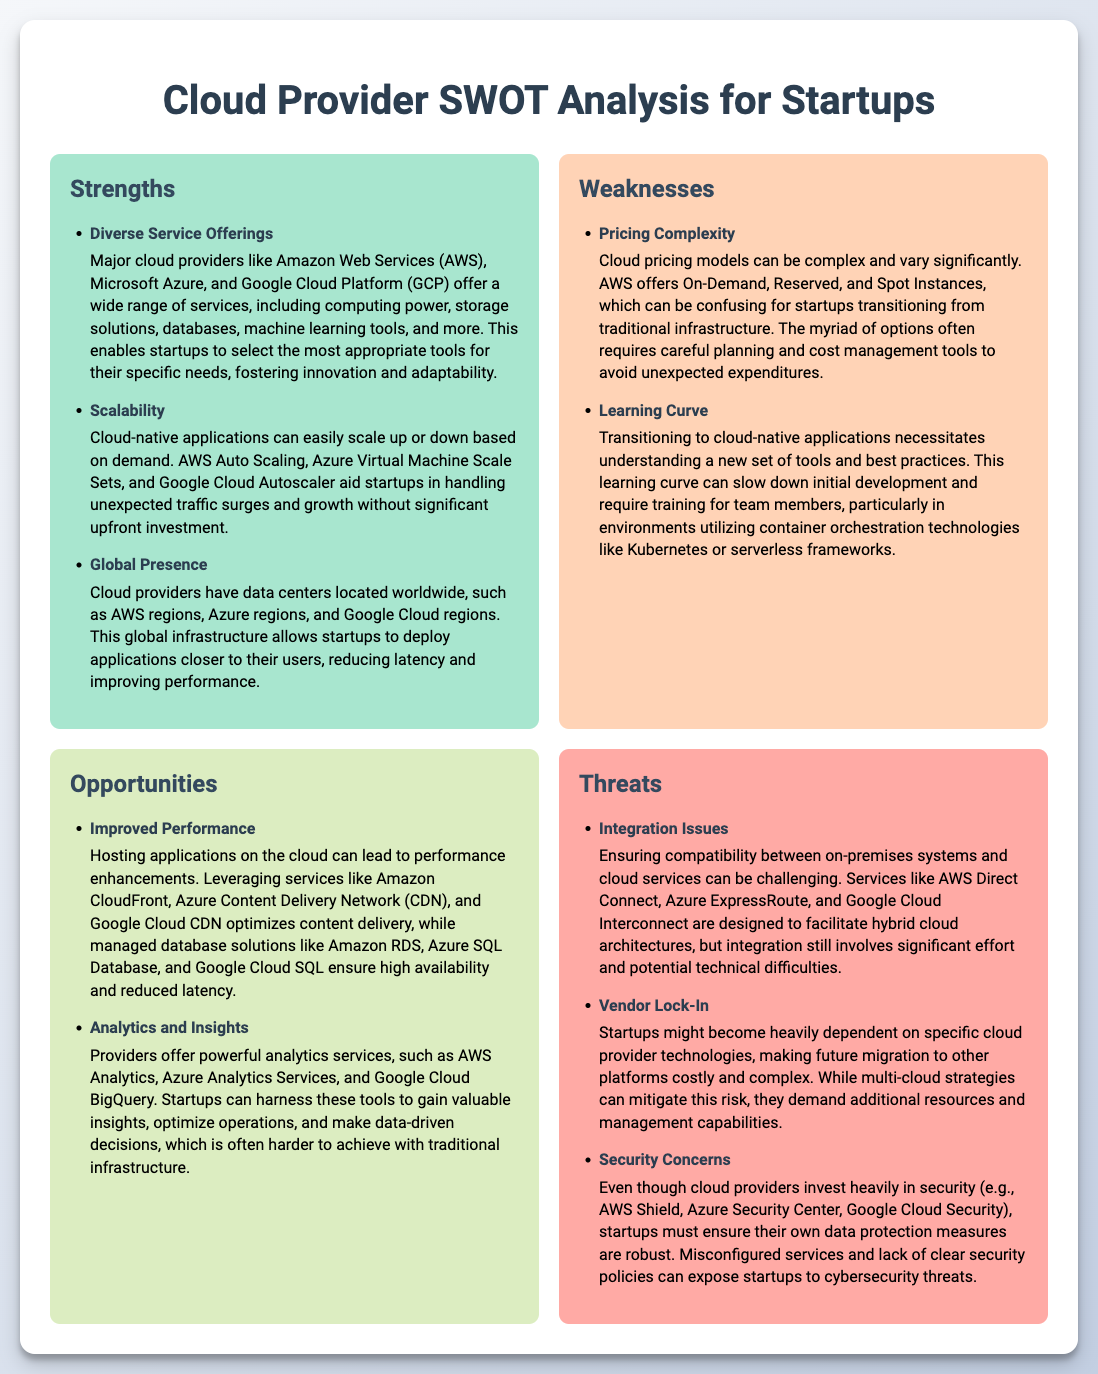What are two strengths mentioned in the analysis? The document lists three strengths under the "Strengths" section; thus, two can be any selection from them.
Answer: Diverse Service Offerings, Scalability What is a major weakness related to cloud pricing? The document specifically mentions this as a complexity that can confuse startups.
Answer: Pricing Complexity How many opportunities are listed in the analysis? The "Opportunities" section outlines two distinct opportunities, which answers the question directly.
Answer: 2 What is one opportunity for startups mentioned in the document? The document provides two opportunities under the "Opportunities" section, and either of them would be correct.
Answer: Improved Performance Name one threat associated with cloud providers as listed in the document. The document provides three specific threats, of which any one can be selected.
Answer: Integration Issues What is one service that helps with application performance? The document mentions several services aimed at performance improvement in a cloud environment.
Answer: Amazon CloudFront How many weaknesses are identified in the analysis? The "Weaknesses" section includes two points specifically outlined regarding challenges for startups.
Answer: 2 What is a security concern highlighted for startups using cloud services? The document mentions this issue concerning data protection in the "Threats" section.
Answer: Security Concerns What facilitates hybrid cloud architectures as per the document? The document specifically details services designed for integration between on-premises systems and cloud services.
Answer: AWS Direct Connect 